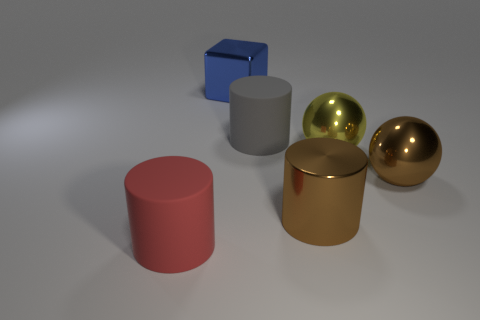Is the number of big brown metal balls that are to the left of the gray cylinder less than the number of gray things?
Your response must be concise. Yes. What number of large metallic objects are in front of the large yellow sphere?
Provide a succinct answer. 2. Does the big matte object to the right of the red object have the same shape as the red thing that is in front of the yellow ball?
Offer a very short reply. Yes. There is a shiny thing that is on the right side of the metal cylinder and left of the brown metallic sphere; what is its shape?
Offer a very short reply. Sphere. What size is the yellow object that is the same material as the brown sphere?
Your response must be concise. Large. Is the number of gray metal balls less than the number of large red matte objects?
Keep it short and to the point. Yes. There is a thing on the left side of the shiny object that is behind the large yellow sphere on the right side of the big gray cylinder; what is its material?
Your answer should be very brief. Rubber. Are the big brown object right of the big brown cylinder and the cylinder behind the large brown sphere made of the same material?
Ensure brevity in your answer.  No. What size is the thing that is both left of the large gray cylinder and in front of the big blue metallic block?
Give a very brief answer. Large. What material is the yellow thing that is the same size as the red cylinder?
Your response must be concise. Metal. 